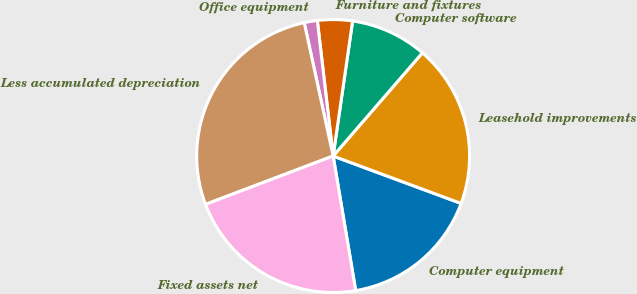Convert chart. <chart><loc_0><loc_0><loc_500><loc_500><pie_chart><fcel>Computer equipment<fcel>Leasehold improvements<fcel>Computer software<fcel>Furniture and fixtures<fcel>Office equipment<fcel>Less accumulated depreciation<fcel>Fixed assets net<nl><fcel>16.71%<fcel>19.3%<fcel>9.07%<fcel>4.13%<fcel>1.55%<fcel>27.37%<fcel>21.88%<nl></chart> 